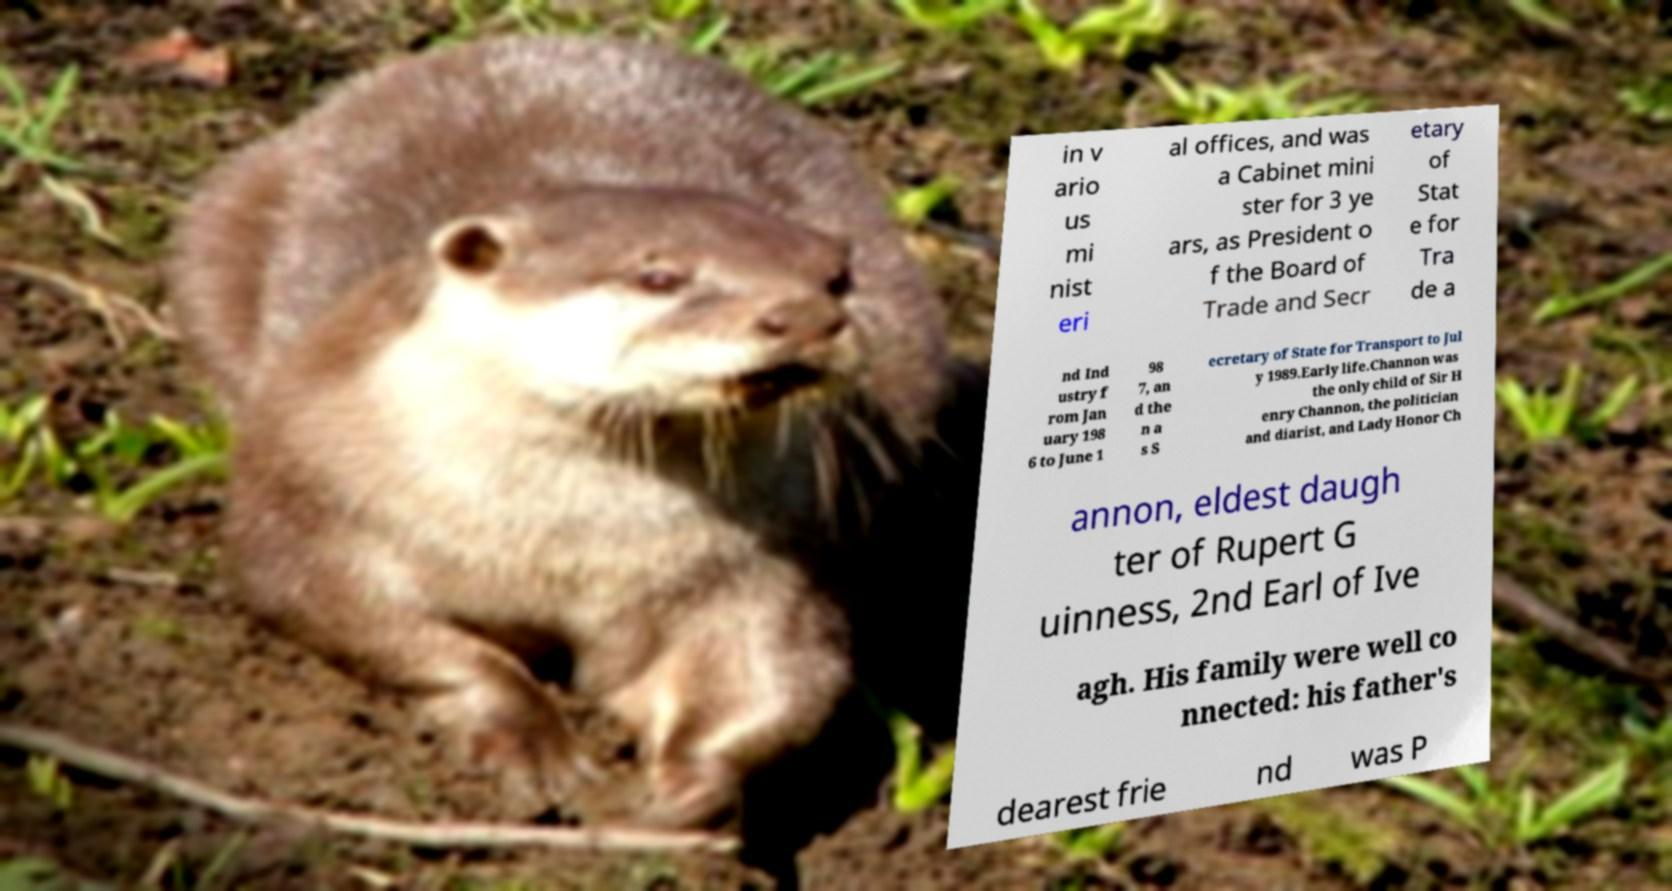Could you assist in decoding the text presented in this image and type it out clearly? in v ario us mi nist eri al offices, and was a Cabinet mini ster for 3 ye ars, as President o f the Board of Trade and Secr etary of Stat e for Tra de a nd Ind ustry f rom Jan uary 198 6 to June 1 98 7, an d the n a s S ecretary of State for Transport to Jul y 1989.Early life.Channon was the only child of Sir H enry Channon, the politician and diarist, and Lady Honor Ch annon, eldest daugh ter of Rupert G uinness, 2nd Earl of Ive agh. His family were well co nnected: his father's dearest frie nd was P 